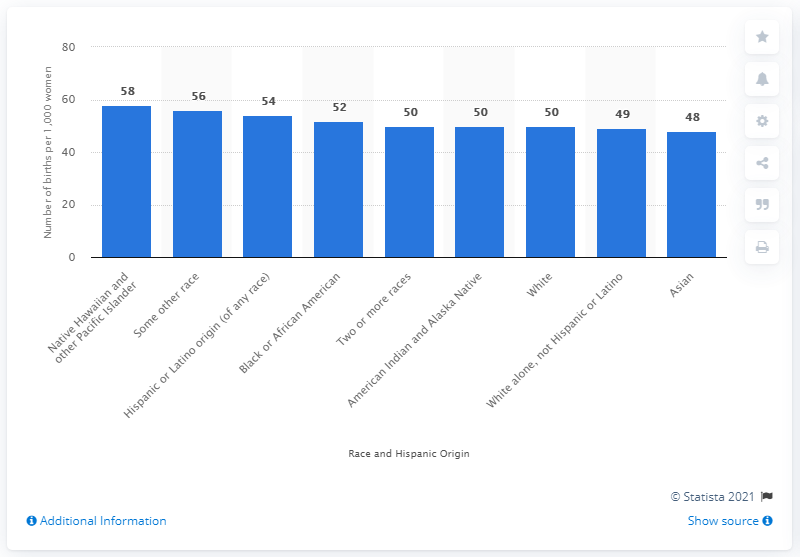Highlight a few significant elements in this photo. In 2019, approximately 48 children per thousand Asian women were born in the United States. 